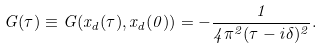<formula> <loc_0><loc_0><loc_500><loc_500>G ( \tau ) \equiv G ( x _ { d } ( \tau ) , x _ { d } ( 0 ) ) = - \frac { 1 } { 4 \pi ^ { 2 } ( \tau - i \delta ) ^ { 2 } } .</formula> 